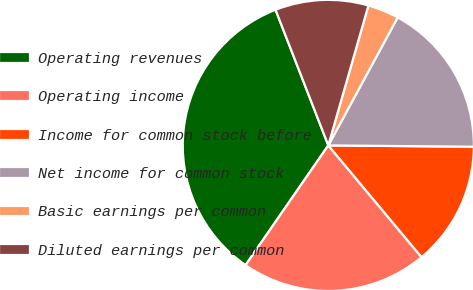Convert chart. <chart><loc_0><loc_0><loc_500><loc_500><pie_chart><fcel>Operating revenues<fcel>Operating income<fcel>Income for common stock before<fcel>Net income for common stock<fcel>Basic earnings per common<fcel>Diluted earnings per common<nl><fcel>34.47%<fcel>20.69%<fcel>13.79%<fcel>17.24%<fcel>3.46%<fcel>10.35%<nl></chart> 